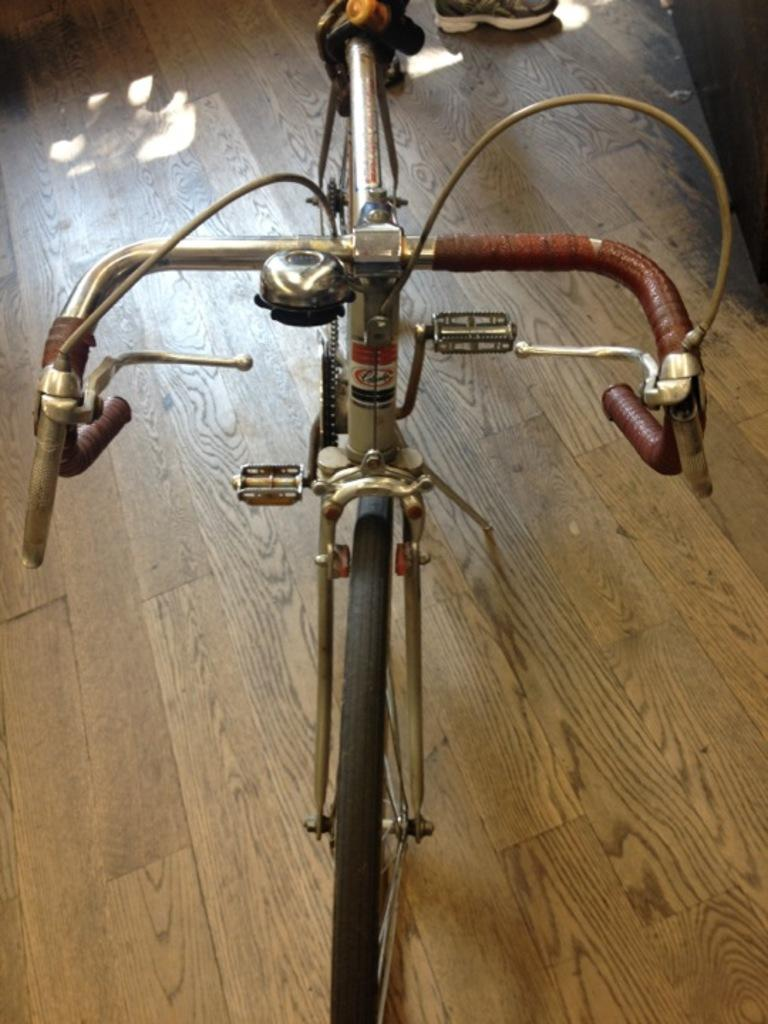What is the main object in the foreground of the image? There is a bicycle in the foreground of the image. Can you describe the person in the image? There is a person at the back of the image. What type of flooring is visible in the image? There is a wooden floor in the image. What type of record can be seen spinning on the playground in the image? There is no record or playground present in the image; it features a bicycle and a person on a wooden floor. 